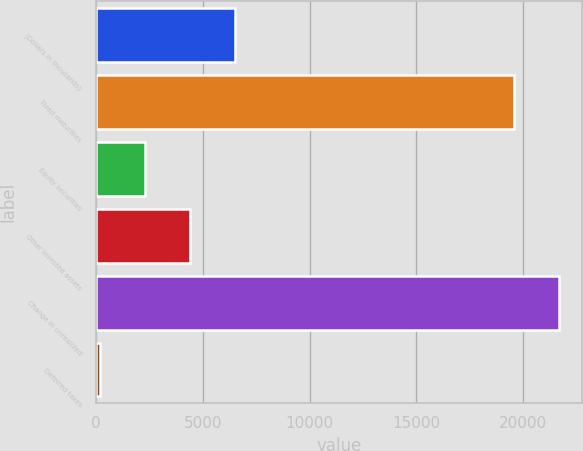Convert chart. <chart><loc_0><loc_0><loc_500><loc_500><bar_chart><fcel>(Dollars in thousands)<fcel>Fixed maturities<fcel>Equity securities<fcel>Other invested assets<fcel>Change in unrealized<fcel>Deferred taxes<nl><fcel>6531.7<fcel>19546<fcel>2295.9<fcel>4413.8<fcel>21663.9<fcel>178<nl></chart> 